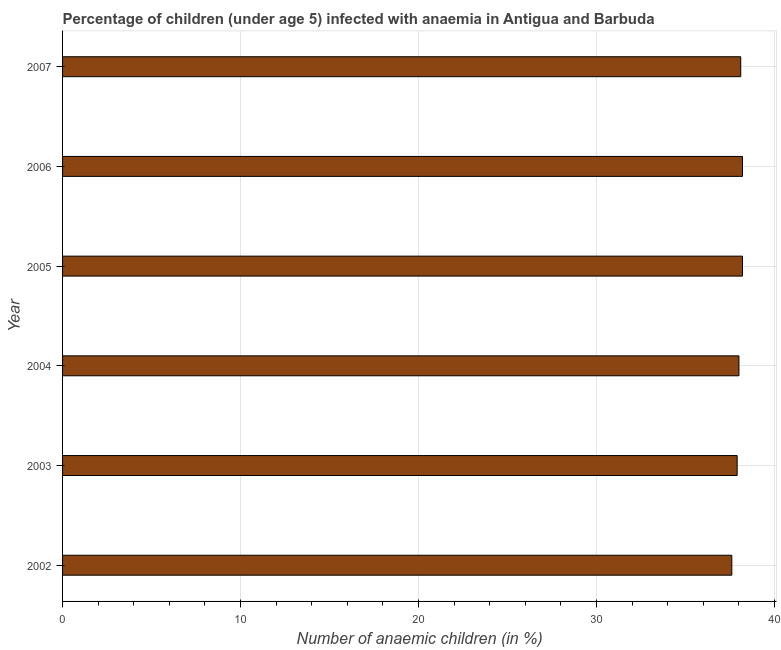What is the title of the graph?
Make the answer very short. Percentage of children (under age 5) infected with anaemia in Antigua and Barbuda. What is the label or title of the X-axis?
Your answer should be very brief. Number of anaemic children (in %). What is the label or title of the Y-axis?
Ensure brevity in your answer.  Year. What is the number of anaemic children in 2003?
Give a very brief answer. 37.9. Across all years, what is the maximum number of anaemic children?
Keep it short and to the point. 38.2. Across all years, what is the minimum number of anaemic children?
Provide a succinct answer. 37.6. What is the sum of the number of anaemic children?
Provide a short and direct response. 228. What is the average number of anaemic children per year?
Keep it short and to the point. 38. What is the median number of anaemic children?
Provide a short and direct response. 38.05. Do a majority of the years between 2006 and 2007 (inclusive) have number of anaemic children greater than 34 %?
Ensure brevity in your answer.  Yes. What is the ratio of the number of anaemic children in 2002 to that in 2005?
Your answer should be very brief. 0.98. What is the difference between the highest and the second highest number of anaemic children?
Give a very brief answer. 0. Is the sum of the number of anaemic children in 2005 and 2007 greater than the maximum number of anaemic children across all years?
Provide a short and direct response. Yes. What is the difference between the highest and the lowest number of anaemic children?
Your response must be concise. 0.6. How many bars are there?
Give a very brief answer. 6. What is the difference between two consecutive major ticks on the X-axis?
Give a very brief answer. 10. Are the values on the major ticks of X-axis written in scientific E-notation?
Make the answer very short. No. What is the Number of anaemic children (in %) in 2002?
Make the answer very short. 37.6. What is the Number of anaemic children (in %) in 2003?
Offer a terse response. 37.9. What is the Number of anaemic children (in %) in 2005?
Offer a very short reply. 38.2. What is the Number of anaemic children (in %) in 2006?
Your response must be concise. 38.2. What is the Number of anaemic children (in %) in 2007?
Your answer should be compact. 38.1. What is the difference between the Number of anaemic children (in %) in 2002 and 2007?
Offer a very short reply. -0.5. What is the difference between the Number of anaemic children (in %) in 2003 and 2005?
Offer a terse response. -0.3. What is the difference between the Number of anaemic children (in %) in 2003 and 2006?
Offer a terse response. -0.3. What is the difference between the Number of anaemic children (in %) in 2004 and 2006?
Offer a very short reply. -0.2. What is the difference between the Number of anaemic children (in %) in 2004 and 2007?
Provide a short and direct response. -0.1. What is the difference between the Number of anaemic children (in %) in 2005 and 2006?
Give a very brief answer. 0. What is the ratio of the Number of anaemic children (in %) in 2002 to that in 2005?
Provide a short and direct response. 0.98. What is the ratio of the Number of anaemic children (in %) in 2002 to that in 2006?
Provide a short and direct response. 0.98. What is the ratio of the Number of anaemic children (in %) in 2003 to that in 2004?
Make the answer very short. 1. What is the ratio of the Number of anaemic children (in %) in 2003 to that in 2006?
Your answer should be very brief. 0.99. What is the ratio of the Number of anaemic children (in %) in 2003 to that in 2007?
Your answer should be compact. 0.99. What is the ratio of the Number of anaemic children (in %) in 2004 to that in 2006?
Make the answer very short. 0.99. What is the ratio of the Number of anaemic children (in %) in 2004 to that in 2007?
Make the answer very short. 1. What is the ratio of the Number of anaemic children (in %) in 2005 to that in 2006?
Give a very brief answer. 1. What is the ratio of the Number of anaemic children (in %) in 2005 to that in 2007?
Provide a succinct answer. 1. 